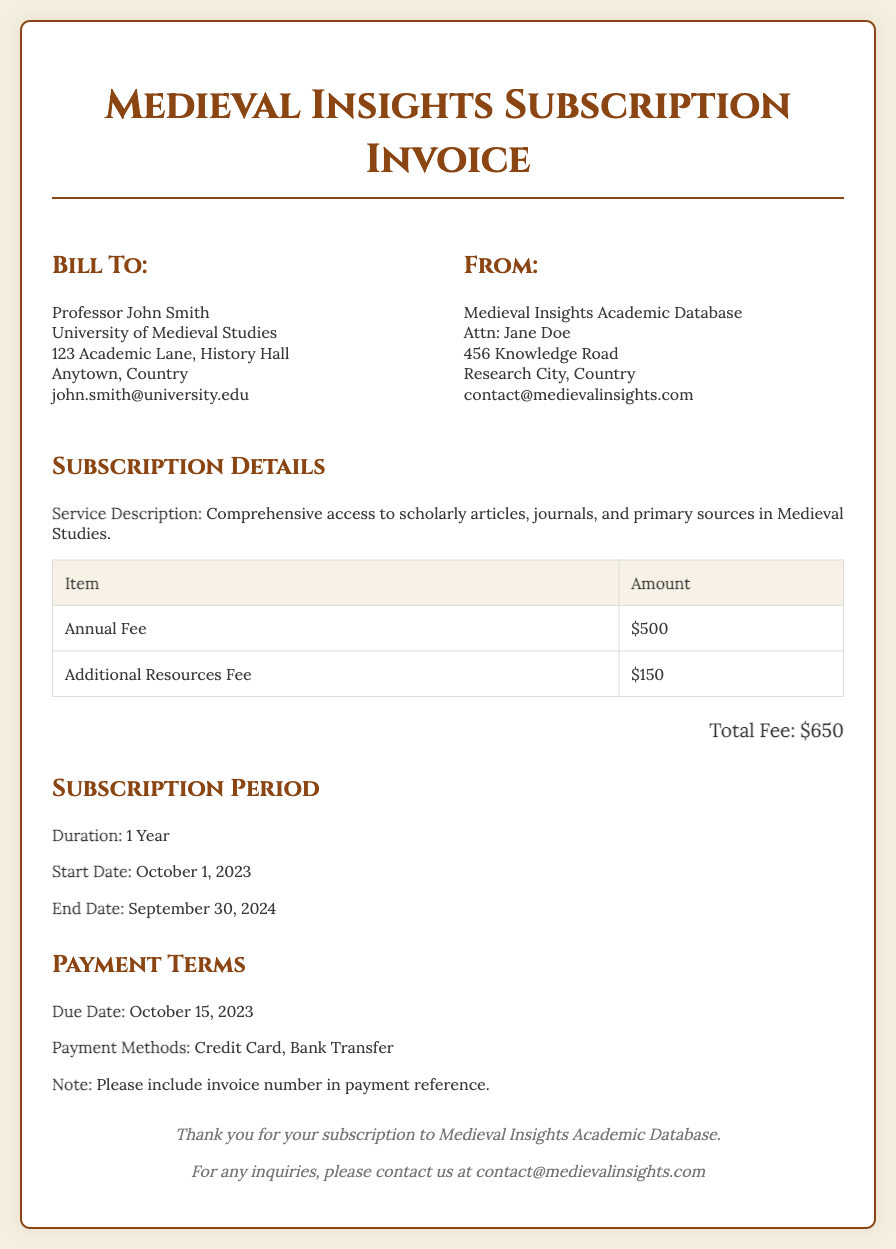what is the total fee? The total fee is listed at the end of the invoice and is the sum of the annual fee and additional resources fee.
Answer: $650 who is the invoice addressed to? The "Bill To" section indicates the person to whom the invoice is addressed.
Answer: Professor John Smith what is the duration of the subscription? The "Subscription Period" section specifies how long the subscription lasts.
Answer: 1 Year when is the due date for payment? The due date is mentioned under "Payment Terms."
Answer: October 15, 2023 what is the annual fee? The invoice lists the annual fee as part of the subscription details.
Answer: $500 who should be contacted for inquiries? The footer provides contact information for inquiries related to the subscription.
Answer: contact@medievalinsights.com when does the subscription start? The start date is provided in the "Subscription Period" section.
Answer: October 1, 2023 what is the additional resources fee? The invoice outlines the fee for additional resources in the subscription details.
Answer: $150 what is the end date of the subscription? The end date is mentioned in the "Subscription Period" section.
Answer: September 30, 2024 